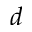<formula> <loc_0><loc_0><loc_500><loc_500>d</formula> 